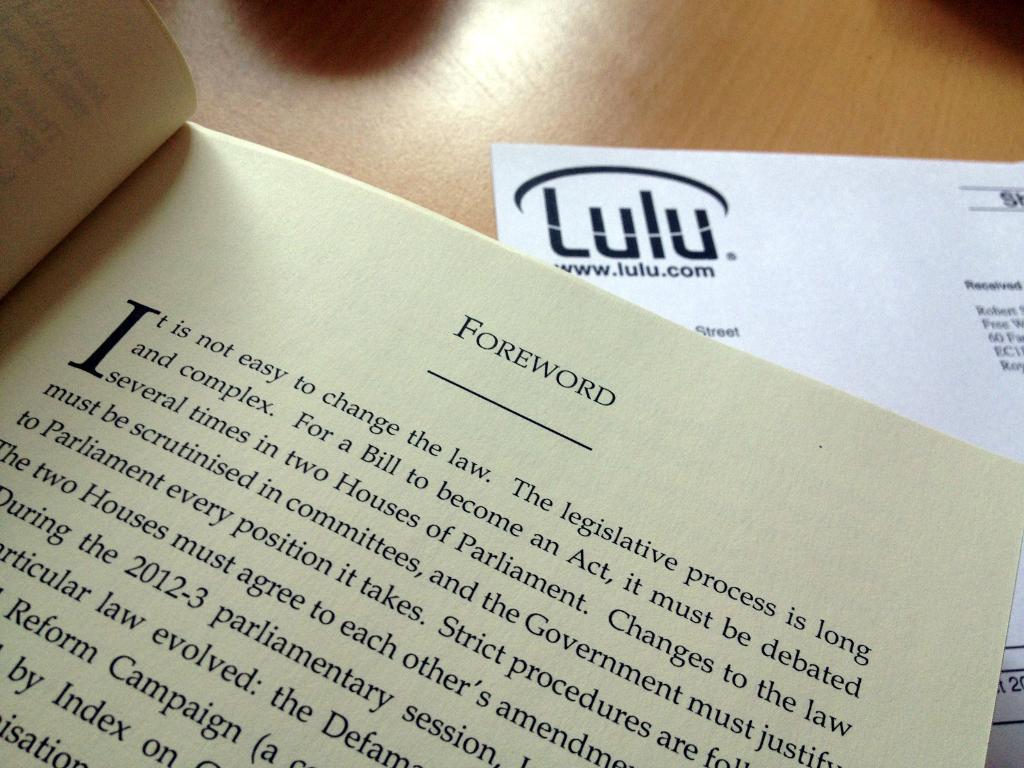Is it easy to change the law?
Offer a terse response. No. What section of the book is being read?
Provide a succinct answer. Foreword. 